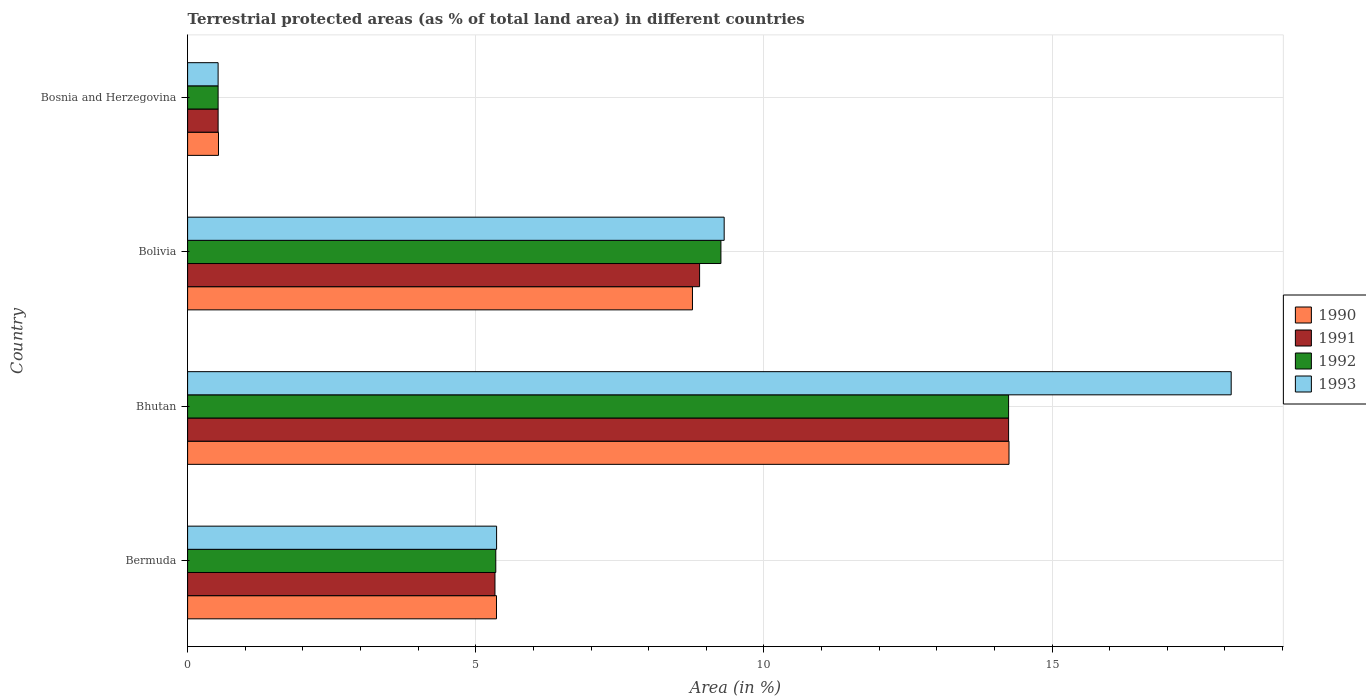Are the number of bars per tick equal to the number of legend labels?
Your answer should be very brief. Yes. How many bars are there on the 1st tick from the bottom?
Your answer should be compact. 4. What is the label of the 1st group of bars from the top?
Provide a succinct answer. Bosnia and Herzegovina. In how many cases, is the number of bars for a given country not equal to the number of legend labels?
Your answer should be very brief. 0. What is the percentage of terrestrial protected land in 1990 in Bermuda?
Ensure brevity in your answer.  5.36. Across all countries, what is the maximum percentage of terrestrial protected land in 1990?
Your answer should be very brief. 14.25. Across all countries, what is the minimum percentage of terrestrial protected land in 1993?
Offer a very short reply. 0.53. In which country was the percentage of terrestrial protected land in 1992 maximum?
Provide a succinct answer. Bhutan. In which country was the percentage of terrestrial protected land in 1993 minimum?
Provide a succinct answer. Bosnia and Herzegovina. What is the total percentage of terrestrial protected land in 1993 in the graph?
Offer a terse response. 33.31. What is the difference between the percentage of terrestrial protected land in 1992 in Bermuda and that in Bosnia and Herzegovina?
Ensure brevity in your answer.  4.82. What is the difference between the percentage of terrestrial protected land in 1991 in Bolivia and the percentage of terrestrial protected land in 1990 in Bosnia and Herzegovina?
Ensure brevity in your answer.  8.35. What is the average percentage of terrestrial protected land in 1993 per country?
Offer a terse response. 8.33. What is the difference between the percentage of terrestrial protected land in 1993 and percentage of terrestrial protected land in 1991 in Bolivia?
Your answer should be very brief. 0.43. What is the ratio of the percentage of terrestrial protected land in 1993 in Bolivia to that in Bosnia and Herzegovina?
Keep it short and to the point. 17.58. Is the difference between the percentage of terrestrial protected land in 1993 in Bolivia and Bosnia and Herzegovina greater than the difference between the percentage of terrestrial protected land in 1991 in Bolivia and Bosnia and Herzegovina?
Keep it short and to the point. Yes. What is the difference between the highest and the second highest percentage of terrestrial protected land in 1990?
Provide a short and direct response. 5.49. What is the difference between the highest and the lowest percentage of terrestrial protected land in 1990?
Keep it short and to the point. 13.72. In how many countries, is the percentage of terrestrial protected land in 1992 greater than the average percentage of terrestrial protected land in 1992 taken over all countries?
Make the answer very short. 2. Is it the case that in every country, the sum of the percentage of terrestrial protected land in 1990 and percentage of terrestrial protected land in 1992 is greater than the sum of percentage of terrestrial protected land in 1991 and percentage of terrestrial protected land in 1993?
Keep it short and to the point. No. What does the 1st bar from the top in Bermuda represents?
Make the answer very short. 1993. Is it the case that in every country, the sum of the percentage of terrestrial protected land in 1993 and percentage of terrestrial protected land in 1992 is greater than the percentage of terrestrial protected land in 1991?
Offer a terse response. Yes. Are all the bars in the graph horizontal?
Give a very brief answer. Yes. How many countries are there in the graph?
Your answer should be very brief. 4. What is the difference between two consecutive major ticks on the X-axis?
Make the answer very short. 5. Are the values on the major ticks of X-axis written in scientific E-notation?
Provide a succinct answer. No. Does the graph contain any zero values?
Your answer should be compact. No. Does the graph contain grids?
Provide a succinct answer. Yes. Where does the legend appear in the graph?
Offer a terse response. Center right. How many legend labels are there?
Make the answer very short. 4. How are the legend labels stacked?
Your response must be concise. Vertical. What is the title of the graph?
Provide a succinct answer. Terrestrial protected areas (as % of total land area) in different countries. Does "1964" appear as one of the legend labels in the graph?
Offer a very short reply. No. What is the label or title of the X-axis?
Your answer should be compact. Area (in %). What is the label or title of the Y-axis?
Your answer should be compact. Country. What is the Area (in %) of 1990 in Bermuda?
Give a very brief answer. 5.36. What is the Area (in %) in 1991 in Bermuda?
Provide a short and direct response. 5.33. What is the Area (in %) of 1992 in Bermuda?
Offer a very short reply. 5.35. What is the Area (in %) in 1993 in Bermuda?
Your response must be concise. 5.36. What is the Area (in %) in 1990 in Bhutan?
Ensure brevity in your answer.  14.25. What is the Area (in %) of 1991 in Bhutan?
Your answer should be compact. 14.25. What is the Area (in %) in 1992 in Bhutan?
Make the answer very short. 14.25. What is the Area (in %) of 1993 in Bhutan?
Your response must be concise. 18.11. What is the Area (in %) of 1990 in Bolivia?
Make the answer very short. 8.76. What is the Area (in %) of 1991 in Bolivia?
Provide a short and direct response. 8.88. What is the Area (in %) of 1992 in Bolivia?
Give a very brief answer. 9.25. What is the Area (in %) of 1993 in Bolivia?
Provide a succinct answer. 9.31. What is the Area (in %) in 1990 in Bosnia and Herzegovina?
Offer a terse response. 0.54. What is the Area (in %) in 1991 in Bosnia and Herzegovina?
Your answer should be very brief. 0.53. What is the Area (in %) of 1992 in Bosnia and Herzegovina?
Provide a short and direct response. 0.53. What is the Area (in %) in 1993 in Bosnia and Herzegovina?
Provide a short and direct response. 0.53. Across all countries, what is the maximum Area (in %) of 1990?
Your answer should be compact. 14.25. Across all countries, what is the maximum Area (in %) in 1991?
Give a very brief answer. 14.25. Across all countries, what is the maximum Area (in %) of 1992?
Your answer should be compact. 14.25. Across all countries, what is the maximum Area (in %) of 1993?
Offer a terse response. 18.11. Across all countries, what is the minimum Area (in %) in 1990?
Provide a short and direct response. 0.54. Across all countries, what is the minimum Area (in %) of 1991?
Keep it short and to the point. 0.53. Across all countries, what is the minimum Area (in %) in 1992?
Provide a short and direct response. 0.53. Across all countries, what is the minimum Area (in %) in 1993?
Your answer should be compact. 0.53. What is the total Area (in %) in 1990 in the graph?
Provide a short and direct response. 28.91. What is the total Area (in %) of 1991 in the graph?
Keep it short and to the point. 28.99. What is the total Area (in %) of 1992 in the graph?
Give a very brief answer. 29.38. What is the total Area (in %) of 1993 in the graph?
Your response must be concise. 33.31. What is the difference between the Area (in %) of 1990 in Bermuda and that in Bhutan?
Provide a succinct answer. -8.89. What is the difference between the Area (in %) of 1991 in Bermuda and that in Bhutan?
Provide a succinct answer. -8.91. What is the difference between the Area (in %) of 1992 in Bermuda and that in Bhutan?
Keep it short and to the point. -8.9. What is the difference between the Area (in %) in 1993 in Bermuda and that in Bhutan?
Ensure brevity in your answer.  -12.75. What is the difference between the Area (in %) in 1990 in Bermuda and that in Bolivia?
Give a very brief answer. -3.4. What is the difference between the Area (in %) in 1991 in Bermuda and that in Bolivia?
Your response must be concise. -3.55. What is the difference between the Area (in %) in 1992 in Bermuda and that in Bolivia?
Make the answer very short. -3.91. What is the difference between the Area (in %) in 1993 in Bermuda and that in Bolivia?
Ensure brevity in your answer.  -3.95. What is the difference between the Area (in %) of 1990 in Bermuda and that in Bosnia and Herzegovina?
Make the answer very short. 4.82. What is the difference between the Area (in %) in 1991 in Bermuda and that in Bosnia and Herzegovina?
Make the answer very short. 4.8. What is the difference between the Area (in %) of 1992 in Bermuda and that in Bosnia and Herzegovina?
Give a very brief answer. 4.82. What is the difference between the Area (in %) of 1993 in Bermuda and that in Bosnia and Herzegovina?
Provide a succinct answer. 4.83. What is the difference between the Area (in %) in 1990 in Bhutan and that in Bolivia?
Give a very brief answer. 5.49. What is the difference between the Area (in %) in 1991 in Bhutan and that in Bolivia?
Provide a succinct answer. 5.36. What is the difference between the Area (in %) in 1992 in Bhutan and that in Bolivia?
Make the answer very short. 4.99. What is the difference between the Area (in %) of 1993 in Bhutan and that in Bolivia?
Give a very brief answer. 8.8. What is the difference between the Area (in %) of 1990 in Bhutan and that in Bosnia and Herzegovina?
Give a very brief answer. 13.72. What is the difference between the Area (in %) in 1991 in Bhutan and that in Bosnia and Herzegovina?
Your response must be concise. 13.72. What is the difference between the Area (in %) of 1992 in Bhutan and that in Bosnia and Herzegovina?
Provide a short and direct response. 13.72. What is the difference between the Area (in %) of 1993 in Bhutan and that in Bosnia and Herzegovina?
Make the answer very short. 17.58. What is the difference between the Area (in %) in 1990 in Bolivia and that in Bosnia and Herzegovina?
Make the answer very short. 8.22. What is the difference between the Area (in %) in 1991 in Bolivia and that in Bosnia and Herzegovina?
Provide a short and direct response. 8.35. What is the difference between the Area (in %) in 1992 in Bolivia and that in Bosnia and Herzegovina?
Your answer should be compact. 8.72. What is the difference between the Area (in %) of 1993 in Bolivia and that in Bosnia and Herzegovina?
Ensure brevity in your answer.  8.78. What is the difference between the Area (in %) in 1990 in Bermuda and the Area (in %) in 1991 in Bhutan?
Give a very brief answer. -8.89. What is the difference between the Area (in %) in 1990 in Bermuda and the Area (in %) in 1992 in Bhutan?
Provide a short and direct response. -8.89. What is the difference between the Area (in %) in 1990 in Bermuda and the Area (in %) in 1993 in Bhutan?
Ensure brevity in your answer.  -12.75. What is the difference between the Area (in %) in 1991 in Bermuda and the Area (in %) in 1992 in Bhutan?
Provide a short and direct response. -8.91. What is the difference between the Area (in %) in 1991 in Bermuda and the Area (in %) in 1993 in Bhutan?
Your response must be concise. -12.77. What is the difference between the Area (in %) of 1992 in Bermuda and the Area (in %) of 1993 in Bhutan?
Your response must be concise. -12.76. What is the difference between the Area (in %) of 1990 in Bermuda and the Area (in %) of 1991 in Bolivia?
Make the answer very short. -3.52. What is the difference between the Area (in %) of 1990 in Bermuda and the Area (in %) of 1992 in Bolivia?
Your answer should be very brief. -3.89. What is the difference between the Area (in %) of 1990 in Bermuda and the Area (in %) of 1993 in Bolivia?
Make the answer very short. -3.95. What is the difference between the Area (in %) in 1991 in Bermuda and the Area (in %) in 1992 in Bolivia?
Offer a terse response. -3.92. What is the difference between the Area (in %) in 1991 in Bermuda and the Area (in %) in 1993 in Bolivia?
Provide a short and direct response. -3.98. What is the difference between the Area (in %) of 1992 in Bermuda and the Area (in %) of 1993 in Bolivia?
Your answer should be compact. -3.96. What is the difference between the Area (in %) in 1990 in Bermuda and the Area (in %) in 1991 in Bosnia and Herzegovina?
Ensure brevity in your answer.  4.83. What is the difference between the Area (in %) of 1990 in Bermuda and the Area (in %) of 1992 in Bosnia and Herzegovina?
Your answer should be compact. 4.83. What is the difference between the Area (in %) in 1990 in Bermuda and the Area (in %) in 1993 in Bosnia and Herzegovina?
Make the answer very short. 4.83. What is the difference between the Area (in %) of 1991 in Bermuda and the Area (in %) of 1992 in Bosnia and Herzegovina?
Provide a succinct answer. 4.8. What is the difference between the Area (in %) of 1991 in Bermuda and the Area (in %) of 1993 in Bosnia and Herzegovina?
Offer a terse response. 4.8. What is the difference between the Area (in %) in 1992 in Bermuda and the Area (in %) in 1993 in Bosnia and Herzegovina?
Give a very brief answer. 4.82. What is the difference between the Area (in %) of 1990 in Bhutan and the Area (in %) of 1991 in Bolivia?
Your answer should be very brief. 5.37. What is the difference between the Area (in %) of 1990 in Bhutan and the Area (in %) of 1992 in Bolivia?
Ensure brevity in your answer.  5. What is the difference between the Area (in %) in 1990 in Bhutan and the Area (in %) in 1993 in Bolivia?
Offer a very short reply. 4.94. What is the difference between the Area (in %) of 1991 in Bhutan and the Area (in %) of 1992 in Bolivia?
Give a very brief answer. 4.99. What is the difference between the Area (in %) of 1991 in Bhutan and the Area (in %) of 1993 in Bolivia?
Ensure brevity in your answer.  4.94. What is the difference between the Area (in %) in 1992 in Bhutan and the Area (in %) in 1993 in Bolivia?
Give a very brief answer. 4.94. What is the difference between the Area (in %) in 1990 in Bhutan and the Area (in %) in 1991 in Bosnia and Herzegovina?
Provide a short and direct response. 13.72. What is the difference between the Area (in %) of 1990 in Bhutan and the Area (in %) of 1992 in Bosnia and Herzegovina?
Offer a very short reply. 13.72. What is the difference between the Area (in %) of 1990 in Bhutan and the Area (in %) of 1993 in Bosnia and Herzegovina?
Your answer should be compact. 13.72. What is the difference between the Area (in %) of 1991 in Bhutan and the Area (in %) of 1992 in Bosnia and Herzegovina?
Ensure brevity in your answer.  13.72. What is the difference between the Area (in %) in 1991 in Bhutan and the Area (in %) in 1993 in Bosnia and Herzegovina?
Provide a succinct answer. 13.72. What is the difference between the Area (in %) in 1992 in Bhutan and the Area (in %) in 1993 in Bosnia and Herzegovina?
Provide a succinct answer. 13.72. What is the difference between the Area (in %) of 1990 in Bolivia and the Area (in %) of 1991 in Bosnia and Herzegovina?
Your answer should be very brief. 8.23. What is the difference between the Area (in %) of 1990 in Bolivia and the Area (in %) of 1992 in Bosnia and Herzegovina?
Ensure brevity in your answer.  8.23. What is the difference between the Area (in %) of 1990 in Bolivia and the Area (in %) of 1993 in Bosnia and Herzegovina?
Your answer should be compact. 8.23. What is the difference between the Area (in %) in 1991 in Bolivia and the Area (in %) in 1992 in Bosnia and Herzegovina?
Keep it short and to the point. 8.35. What is the difference between the Area (in %) in 1991 in Bolivia and the Area (in %) in 1993 in Bosnia and Herzegovina?
Your answer should be very brief. 8.35. What is the difference between the Area (in %) of 1992 in Bolivia and the Area (in %) of 1993 in Bosnia and Herzegovina?
Give a very brief answer. 8.72. What is the average Area (in %) in 1990 per country?
Your answer should be very brief. 7.23. What is the average Area (in %) of 1991 per country?
Offer a very short reply. 7.25. What is the average Area (in %) in 1992 per country?
Make the answer very short. 7.34. What is the average Area (in %) in 1993 per country?
Offer a very short reply. 8.33. What is the difference between the Area (in %) in 1990 and Area (in %) in 1991 in Bermuda?
Your answer should be very brief. 0.03. What is the difference between the Area (in %) in 1990 and Area (in %) in 1992 in Bermuda?
Your response must be concise. 0.01. What is the difference between the Area (in %) in 1990 and Area (in %) in 1993 in Bermuda?
Your answer should be very brief. -0. What is the difference between the Area (in %) of 1991 and Area (in %) of 1992 in Bermuda?
Your answer should be compact. -0.01. What is the difference between the Area (in %) of 1991 and Area (in %) of 1993 in Bermuda?
Your answer should be compact. -0.03. What is the difference between the Area (in %) in 1992 and Area (in %) in 1993 in Bermuda?
Your answer should be very brief. -0.01. What is the difference between the Area (in %) in 1990 and Area (in %) in 1991 in Bhutan?
Your answer should be compact. 0.01. What is the difference between the Area (in %) in 1990 and Area (in %) in 1992 in Bhutan?
Your answer should be compact. 0.01. What is the difference between the Area (in %) of 1990 and Area (in %) of 1993 in Bhutan?
Keep it short and to the point. -3.86. What is the difference between the Area (in %) in 1991 and Area (in %) in 1992 in Bhutan?
Provide a short and direct response. 0. What is the difference between the Area (in %) in 1991 and Area (in %) in 1993 in Bhutan?
Your answer should be compact. -3.86. What is the difference between the Area (in %) in 1992 and Area (in %) in 1993 in Bhutan?
Your response must be concise. -3.86. What is the difference between the Area (in %) of 1990 and Area (in %) of 1991 in Bolivia?
Your answer should be very brief. -0.12. What is the difference between the Area (in %) in 1990 and Area (in %) in 1992 in Bolivia?
Keep it short and to the point. -0.49. What is the difference between the Area (in %) in 1990 and Area (in %) in 1993 in Bolivia?
Ensure brevity in your answer.  -0.55. What is the difference between the Area (in %) in 1991 and Area (in %) in 1992 in Bolivia?
Your response must be concise. -0.37. What is the difference between the Area (in %) in 1991 and Area (in %) in 1993 in Bolivia?
Your answer should be very brief. -0.43. What is the difference between the Area (in %) of 1992 and Area (in %) of 1993 in Bolivia?
Give a very brief answer. -0.06. What is the difference between the Area (in %) of 1990 and Area (in %) of 1991 in Bosnia and Herzegovina?
Your answer should be very brief. 0.01. What is the difference between the Area (in %) of 1990 and Area (in %) of 1992 in Bosnia and Herzegovina?
Provide a short and direct response. 0.01. What is the difference between the Area (in %) in 1990 and Area (in %) in 1993 in Bosnia and Herzegovina?
Provide a succinct answer. 0.01. What is the difference between the Area (in %) in 1991 and Area (in %) in 1992 in Bosnia and Herzegovina?
Offer a terse response. 0. What is the ratio of the Area (in %) of 1990 in Bermuda to that in Bhutan?
Your answer should be very brief. 0.38. What is the ratio of the Area (in %) in 1991 in Bermuda to that in Bhutan?
Give a very brief answer. 0.37. What is the ratio of the Area (in %) of 1992 in Bermuda to that in Bhutan?
Offer a very short reply. 0.38. What is the ratio of the Area (in %) of 1993 in Bermuda to that in Bhutan?
Give a very brief answer. 0.3. What is the ratio of the Area (in %) of 1990 in Bermuda to that in Bolivia?
Your response must be concise. 0.61. What is the ratio of the Area (in %) in 1991 in Bermuda to that in Bolivia?
Ensure brevity in your answer.  0.6. What is the ratio of the Area (in %) in 1992 in Bermuda to that in Bolivia?
Make the answer very short. 0.58. What is the ratio of the Area (in %) of 1993 in Bermuda to that in Bolivia?
Your answer should be compact. 0.58. What is the ratio of the Area (in %) of 1990 in Bermuda to that in Bosnia and Herzegovina?
Offer a terse response. 10. What is the ratio of the Area (in %) in 1991 in Bermuda to that in Bosnia and Herzegovina?
Keep it short and to the point. 10.07. What is the ratio of the Area (in %) in 1992 in Bermuda to that in Bosnia and Herzegovina?
Offer a terse response. 10.1. What is the ratio of the Area (in %) of 1993 in Bermuda to that in Bosnia and Herzegovina?
Your answer should be very brief. 10.13. What is the ratio of the Area (in %) in 1990 in Bhutan to that in Bolivia?
Your response must be concise. 1.63. What is the ratio of the Area (in %) of 1991 in Bhutan to that in Bolivia?
Your answer should be very brief. 1.6. What is the ratio of the Area (in %) in 1992 in Bhutan to that in Bolivia?
Offer a very short reply. 1.54. What is the ratio of the Area (in %) of 1993 in Bhutan to that in Bolivia?
Give a very brief answer. 1.94. What is the ratio of the Area (in %) in 1990 in Bhutan to that in Bosnia and Herzegovina?
Provide a short and direct response. 26.59. What is the ratio of the Area (in %) in 1991 in Bhutan to that in Bosnia and Herzegovina?
Keep it short and to the point. 26.9. What is the ratio of the Area (in %) of 1992 in Bhutan to that in Bosnia and Herzegovina?
Make the answer very short. 26.9. What is the ratio of the Area (in %) in 1993 in Bhutan to that in Bosnia and Herzegovina?
Ensure brevity in your answer.  34.2. What is the ratio of the Area (in %) in 1990 in Bolivia to that in Bosnia and Herzegovina?
Keep it short and to the point. 16.34. What is the ratio of the Area (in %) in 1991 in Bolivia to that in Bosnia and Herzegovina?
Keep it short and to the point. 16.78. What is the ratio of the Area (in %) in 1992 in Bolivia to that in Bosnia and Herzegovina?
Offer a terse response. 17.48. What is the ratio of the Area (in %) in 1993 in Bolivia to that in Bosnia and Herzegovina?
Provide a succinct answer. 17.58. What is the difference between the highest and the second highest Area (in %) of 1990?
Ensure brevity in your answer.  5.49. What is the difference between the highest and the second highest Area (in %) in 1991?
Provide a short and direct response. 5.36. What is the difference between the highest and the second highest Area (in %) of 1992?
Provide a succinct answer. 4.99. What is the difference between the highest and the second highest Area (in %) of 1993?
Ensure brevity in your answer.  8.8. What is the difference between the highest and the lowest Area (in %) of 1990?
Provide a succinct answer. 13.72. What is the difference between the highest and the lowest Area (in %) in 1991?
Offer a terse response. 13.72. What is the difference between the highest and the lowest Area (in %) in 1992?
Your answer should be very brief. 13.72. What is the difference between the highest and the lowest Area (in %) in 1993?
Keep it short and to the point. 17.58. 